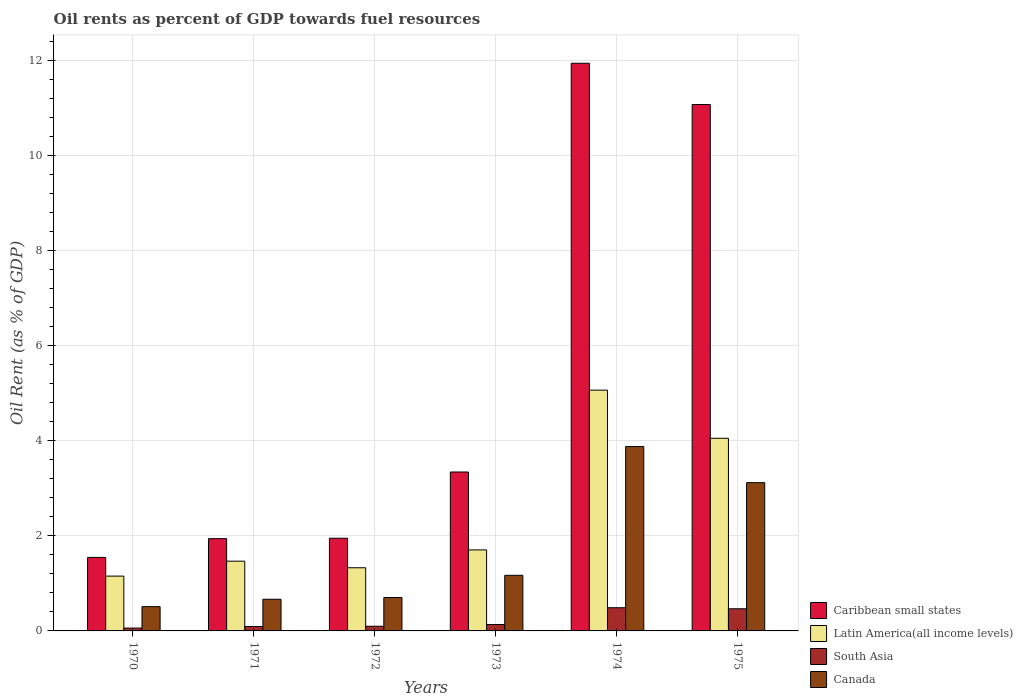How many bars are there on the 1st tick from the left?
Your answer should be compact. 4. How many bars are there on the 6th tick from the right?
Your answer should be compact. 4. What is the label of the 3rd group of bars from the left?
Keep it short and to the point. 1972. In how many cases, is the number of bars for a given year not equal to the number of legend labels?
Keep it short and to the point. 0. What is the oil rent in Canada in 1971?
Offer a terse response. 0.67. Across all years, what is the maximum oil rent in Latin America(all income levels)?
Your answer should be compact. 5.06. Across all years, what is the minimum oil rent in Canada?
Your answer should be compact. 0.51. In which year was the oil rent in Latin America(all income levels) maximum?
Your answer should be compact. 1974. In which year was the oil rent in South Asia minimum?
Provide a short and direct response. 1970. What is the total oil rent in Latin America(all income levels) in the graph?
Your answer should be compact. 14.76. What is the difference between the oil rent in South Asia in 1970 and that in 1971?
Keep it short and to the point. -0.03. What is the difference between the oil rent in Latin America(all income levels) in 1970 and the oil rent in Caribbean small states in 1972?
Offer a very short reply. -0.8. What is the average oil rent in Latin America(all income levels) per year?
Your answer should be very brief. 2.46. In the year 1974, what is the difference between the oil rent in Canada and oil rent in Latin America(all income levels)?
Offer a terse response. -1.19. In how many years, is the oil rent in Canada greater than 4 %?
Provide a short and direct response. 0. What is the ratio of the oil rent in Caribbean small states in 1971 to that in 1975?
Your response must be concise. 0.18. Is the difference between the oil rent in Canada in 1971 and 1973 greater than the difference between the oil rent in Latin America(all income levels) in 1971 and 1973?
Offer a very short reply. No. What is the difference between the highest and the second highest oil rent in Caribbean small states?
Make the answer very short. 0.87. What is the difference between the highest and the lowest oil rent in Caribbean small states?
Keep it short and to the point. 10.39. What does the 3rd bar from the left in 1975 represents?
Offer a terse response. South Asia. What does the 4th bar from the right in 1970 represents?
Your answer should be very brief. Caribbean small states. How many bars are there?
Offer a terse response. 24. Are all the bars in the graph horizontal?
Keep it short and to the point. No. Does the graph contain grids?
Your response must be concise. Yes. How many legend labels are there?
Your answer should be compact. 4. What is the title of the graph?
Ensure brevity in your answer.  Oil rents as percent of GDP towards fuel resources. What is the label or title of the Y-axis?
Your answer should be very brief. Oil Rent (as % of GDP). What is the Oil Rent (as % of GDP) of Caribbean small states in 1970?
Keep it short and to the point. 1.55. What is the Oil Rent (as % of GDP) of Latin America(all income levels) in 1970?
Offer a very short reply. 1.15. What is the Oil Rent (as % of GDP) in South Asia in 1970?
Ensure brevity in your answer.  0.06. What is the Oil Rent (as % of GDP) of Canada in 1970?
Your response must be concise. 0.51. What is the Oil Rent (as % of GDP) of Caribbean small states in 1971?
Keep it short and to the point. 1.94. What is the Oil Rent (as % of GDP) of Latin America(all income levels) in 1971?
Ensure brevity in your answer.  1.47. What is the Oil Rent (as % of GDP) in South Asia in 1971?
Provide a succinct answer. 0.09. What is the Oil Rent (as % of GDP) in Canada in 1971?
Give a very brief answer. 0.67. What is the Oil Rent (as % of GDP) in Caribbean small states in 1972?
Your answer should be very brief. 1.95. What is the Oil Rent (as % of GDP) of Latin America(all income levels) in 1972?
Provide a short and direct response. 1.33. What is the Oil Rent (as % of GDP) in South Asia in 1972?
Provide a short and direct response. 0.1. What is the Oil Rent (as % of GDP) in Canada in 1972?
Your answer should be very brief. 0.7. What is the Oil Rent (as % of GDP) in Caribbean small states in 1973?
Ensure brevity in your answer.  3.34. What is the Oil Rent (as % of GDP) of Latin America(all income levels) in 1973?
Your answer should be very brief. 1.7. What is the Oil Rent (as % of GDP) in South Asia in 1973?
Offer a terse response. 0.14. What is the Oil Rent (as % of GDP) of Canada in 1973?
Make the answer very short. 1.17. What is the Oil Rent (as % of GDP) of Caribbean small states in 1974?
Offer a terse response. 11.94. What is the Oil Rent (as % of GDP) in Latin America(all income levels) in 1974?
Offer a very short reply. 5.06. What is the Oil Rent (as % of GDP) of South Asia in 1974?
Offer a terse response. 0.49. What is the Oil Rent (as % of GDP) of Canada in 1974?
Your answer should be very brief. 3.88. What is the Oil Rent (as % of GDP) of Caribbean small states in 1975?
Your answer should be compact. 11.07. What is the Oil Rent (as % of GDP) in Latin America(all income levels) in 1975?
Provide a succinct answer. 4.05. What is the Oil Rent (as % of GDP) in South Asia in 1975?
Provide a short and direct response. 0.47. What is the Oil Rent (as % of GDP) in Canada in 1975?
Provide a succinct answer. 3.12. Across all years, what is the maximum Oil Rent (as % of GDP) of Caribbean small states?
Make the answer very short. 11.94. Across all years, what is the maximum Oil Rent (as % of GDP) in Latin America(all income levels)?
Your answer should be compact. 5.06. Across all years, what is the maximum Oil Rent (as % of GDP) of South Asia?
Make the answer very short. 0.49. Across all years, what is the maximum Oil Rent (as % of GDP) of Canada?
Ensure brevity in your answer.  3.88. Across all years, what is the minimum Oil Rent (as % of GDP) of Caribbean small states?
Your response must be concise. 1.55. Across all years, what is the minimum Oil Rent (as % of GDP) of Latin America(all income levels)?
Offer a terse response. 1.15. Across all years, what is the minimum Oil Rent (as % of GDP) in South Asia?
Provide a short and direct response. 0.06. Across all years, what is the minimum Oil Rent (as % of GDP) of Canada?
Ensure brevity in your answer.  0.51. What is the total Oil Rent (as % of GDP) of Caribbean small states in the graph?
Your answer should be compact. 31.78. What is the total Oil Rent (as % of GDP) in Latin America(all income levels) in the graph?
Keep it short and to the point. 14.76. What is the total Oil Rent (as % of GDP) in South Asia in the graph?
Your answer should be compact. 1.34. What is the total Oil Rent (as % of GDP) in Canada in the graph?
Provide a short and direct response. 10.04. What is the difference between the Oil Rent (as % of GDP) in Caribbean small states in 1970 and that in 1971?
Provide a succinct answer. -0.39. What is the difference between the Oil Rent (as % of GDP) of Latin America(all income levels) in 1970 and that in 1971?
Offer a very short reply. -0.31. What is the difference between the Oil Rent (as % of GDP) in South Asia in 1970 and that in 1971?
Offer a terse response. -0.03. What is the difference between the Oil Rent (as % of GDP) in Canada in 1970 and that in 1971?
Offer a terse response. -0.16. What is the difference between the Oil Rent (as % of GDP) in Caribbean small states in 1970 and that in 1972?
Ensure brevity in your answer.  -0.4. What is the difference between the Oil Rent (as % of GDP) in Latin America(all income levels) in 1970 and that in 1972?
Make the answer very short. -0.18. What is the difference between the Oil Rent (as % of GDP) of South Asia in 1970 and that in 1972?
Your answer should be very brief. -0.04. What is the difference between the Oil Rent (as % of GDP) of Canada in 1970 and that in 1972?
Offer a terse response. -0.19. What is the difference between the Oil Rent (as % of GDP) in Caribbean small states in 1970 and that in 1973?
Ensure brevity in your answer.  -1.8. What is the difference between the Oil Rent (as % of GDP) in Latin America(all income levels) in 1970 and that in 1973?
Keep it short and to the point. -0.55. What is the difference between the Oil Rent (as % of GDP) in South Asia in 1970 and that in 1973?
Offer a very short reply. -0.08. What is the difference between the Oil Rent (as % of GDP) of Canada in 1970 and that in 1973?
Offer a very short reply. -0.66. What is the difference between the Oil Rent (as % of GDP) of Caribbean small states in 1970 and that in 1974?
Ensure brevity in your answer.  -10.39. What is the difference between the Oil Rent (as % of GDP) in Latin America(all income levels) in 1970 and that in 1974?
Your response must be concise. -3.91. What is the difference between the Oil Rent (as % of GDP) in South Asia in 1970 and that in 1974?
Provide a short and direct response. -0.43. What is the difference between the Oil Rent (as % of GDP) in Canada in 1970 and that in 1974?
Keep it short and to the point. -3.37. What is the difference between the Oil Rent (as % of GDP) in Caribbean small states in 1970 and that in 1975?
Keep it short and to the point. -9.52. What is the difference between the Oil Rent (as % of GDP) in Latin America(all income levels) in 1970 and that in 1975?
Your response must be concise. -2.9. What is the difference between the Oil Rent (as % of GDP) in South Asia in 1970 and that in 1975?
Ensure brevity in your answer.  -0.41. What is the difference between the Oil Rent (as % of GDP) of Canada in 1970 and that in 1975?
Provide a short and direct response. -2.61. What is the difference between the Oil Rent (as % of GDP) in Caribbean small states in 1971 and that in 1972?
Your answer should be very brief. -0.01. What is the difference between the Oil Rent (as % of GDP) of Latin America(all income levels) in 1971 and that in 1972?
Your response must be concise. 0.14. What is the difference between the Oil Rent (as % of GDP) of South Asia in 1971 and that in 1972?
Offer a very short reply. -0.01. What is the difference between the Oil Rent (as % of GDP) of Canada in 1971 and that in 1972?
Give a very brief answer. -0.04. What is the difference between the Oil Rent (as % of GDP) of Caribbean small states in 1971 and that in 1973?
Keep it short and to the point. -1.4. What is the difference between the Oil Rent (as % of GDP) in Latin America(all income levels) in 1971 and that in 1973?
Provide a succinct answer. -0.24. What is the difference between the Oil Rent (as % of GDP) of South Asia in 1971 and that in 1973?
Ensure brevity in your answer.  -0.04. What is the difference between the Oil Rent (as % of GDP) of Canada in 1971 and that in 1973?
Your response must be concise. -0.5. What is the difference between the Oil Rent (as % of GDP) of Caribbean small states in 1971 and that in 1974?
Offer a very short reply. -10. What is the difference between the Oil Rent (as % of GDP) in Latin America(all income levels) in 1971 and that in 1974?
Make the answer very short. -3.6. What is the difference between the Oil Rent (as % of GDP) in South Asia in 1971 and that in 1974?
Give a very brief answer. -0.39. What is the difference between the Oil Rent (as % of GDP) of Canada in 1971 and that in 1974?
Offer a very short reply. -3.21. What is the difference between the Oil Rent (as % of GDP) of Caribbean small states in 1971 and that in 1975?
Keep it short and to the point. -9.13. What is the difference between the Oil Rent (as % of GDP) of Latin America(all income levels) in 1971 and that in 1975?
Provide a short and direct response. -2.58. What is the difference between the Oil Rent (as % of GDP) of South Asia in 1971 and that in 1975?
Your response must be concise. -0.37. What is the difference between the Oil Rent (as % of GDP) of Canada in 1971 and that in 1975?
Your response must be concise. -2.45. What is the difference between the Oil Rent (as % of GDP) in Caribbean small states in 1972 and that in 1973?
Give a very brief answer. -1.39. What is the difference between the Oil Rent (as % of GDP) of Latin America(all income levels) in 1972 and that in 1973?
Offer a terse response. -0.38. What is the difference between the Oil Rent (as % of GDP) in South Asia in 1972 and that in 1973?
Provide a succinct answer. -0.04. What is the difference between the Oil Rent (as % of GDP) in Canada in 1972 and that in 1973?
Your response must be concise. -0.47. What is the difference between the Oil Rent (as % of GDP) in Caribbean small states in 1972 and that in 1974?
Offer a terse response. -9.99. What is the difference between the Oil Rent (as % of GDP) in Latin America(all income levels) in 1972 and that in 1974?
Your answer should be compact. -3.73. What is the difference between the Oil Rent (as % of GDP) of South Asia in 1972 and that in 1974?
Ensure brevity in your answer.  -0.39. What is the difference between the Oil Rent (as % of GDP) of Canada in 1972 and that in 1974?
Your answer should be compact. -3.17. What is the difference between the Oil Rent (as % of GDP) of Caribbean small states in 1972 and that in 1975?
Your response must be concise. -9.12. What is the difference between the Oil Rent (as % of GDP) in Latin America(all income levels) in 1972 and that in 1975?
Offer a terse response. -2.72. What is the difference between the Oil Rent (as % of GDP) in South Asia in 1972 and that in 1975?
Ensure brevity in your answer.  -0.37. What is the difference between the Oil Rent (as % of GDP) of Canada in 1972 and that in 1975?
Your response must be concise. -2.42. What is the difference between the Oil Rent (as % of GDP) of Caribbean small states in 1973 and that in 1974?
Ensure brevity in your answer.  -8.59. What is the difference between the Oil Rent (as % of GDP) in Latin America(all income levels) in 1973 and that in 1974?
Your answer should be very brief. -3.36. What is the difference between the Oil Rent (as % of GDP) of South Asia in 1973 and that in 1974?
Provide a short and direct response. -0.35. What is the difference between the Oil Rent (as % of GDP) in Canada in 1973 and that in 1974?
Offer a very short reply. -2.71. What is the difference between the Oil Rent (as % of GDP) of Caribbean small states in 1973 and that in 1975?
Give a very brief answer. -7.73. What is the difference between the Oil Rent (as % of GDP) in Latin America(all income levels) in 1973 and that in 1975?
Ensure brevity in your answer.  -2.35. What is the difference between the Oil Rent (as % of GDP) of South Asia in 1973 and that in 1975?
Offer a very short reply. -0.33. What is the difference between the Oil Rent (as % of GDP) in Canada in 1973 and that in 1975?
Your answer should be compact. -1.95. What is the difference between the Oil Rent (as % of GDP) of Caribbean small states in 1974 and that in 1975?
Keep it short and to the point. 0.87. What is the difference between the Oil Rent (as % of GDP) in Latin America(all income levels) in 1974 and that in 1975?
Make the answer very short. 1.01. What is the difference between the Oil Rent (as % of GDP) in South Asia in 1974 and that in 1975?
Make the answer very short. 0.02. What is the difference between the Oil Rent (as % of GDP) of Canada in 1974 and that in 1975?
Keep it short and to the point. 0.76. What is the difference between the Oil Rent (as % of GDP) of Caribbean small states in 1970 and the Oil Rent (as % of GDP) of Latin America(all income levels) in 1971?
Provide a succinct answer. 0.08. What is the difference between the Oil Rent (as % of GDP) in Caribbean small states in 1970 and the Oil Rent (as % of GDP) in South Asia in 1971?
Provide a succinct answer. 1.45. What is the difference between the Oil Rent (as % of GDP) of Caribbean small states in 1970 and the Oil Rent (as % of GDP) of Canada in 1971?
Offer a terse response. 0.88. What is the difference between the Oil Rent (as % of GDP) in Latin America(all income levels) in 1970 and the Oil Rent (as % of GDP) in South Asia in 1971?
Your answer should be compact. 1.06. What is the difference between the Oil Rent (as % of GDP) of Latin America(all income levels) in 1970 and the Oil Rent (as % of GDP) of Canada in 1971?
Offer a very short reply. 0.49. What is the difference between the Oil Rent (as % of GDP) in South Asia in 1970 and the Oil Rent (as % of GDP) in Canada in 1971?
Keep it short and to the point. -0.61. What is the difference between the Oil Rent (as % of GDP) of Caribbean small states in 1970 and the Oil Rent (as % of GDP) of Latin America(all income levels) in 1972?
Your response must be concise. 0.22. What is the difference between the Oil Rent (as % of GDP) in Caribbean small states in 1970 and the Oil Rent (as % of GDP) in South Asia in 1972?
Offer a terse response. 1.45. What is the difference between the Oil Rent (as % of GDP) of Caribbean small states in 1970 and the Oil Rent (as % of GDP) of Canada in 1972?
Your answer should be very brief. 0.84. What is the difference between the Oil Rent (as % of GDP) of Latin America(all income levels) in 1970 and the Oil Rent (as % of GDP) of South Asia in 1972?
Give a very brief answer. 1.05. What is the difference between the Oil Rent (as % of GDP) in Latin America(all income levels) in 1970 and the Oil Rent (as % of GDP) in Canada in 1972?
Offer a very short reply. 0.45. What is the difference between the Oil Rent (as % of GDP) of South Asia in 1970 and the Oil Rent (as % of GDP) of Canada in 1972?
Provide a succinct answer. -0.64. What is the difference between the Oil Rent (as % of GDP) of Caribbean small states in 1970 and the Oil Rent (as % of GDP) of Latin America(all income levels) in 1973?
Ensure brevity in your answer.  -0.16. What is the difference between the Oil Rent (as % of GDP) in Caribbean small states in 1970 and the Oil Rent (as % of GDP) in South Asia in 1973?
Give a very brief answer. 1.41. What is the difference between the Oil Rent (as % of GDP) of Caribbean small states in 1970 and the Oil Rent (as % of GDP) of Canada in 1973?
Ensure brevity in your answer.  0.38. What is the difference between the Oil Rent (as % of GDP) in Latin America(all income levels) in 1970 and the Oil Rent (as % of GDP) in South Asia in 1973?
Offer a very short reply. 1.02. What is the difference between the Oil Rent (as % of GDP) in Latin America(all income levels) in 1970 and the Oil Rent (as % of GDP) in Canada in 1973?
Provide a short and direct response. -0.02. What is the difference between the Oil Rent (as % of GDP) of South Asia in 1970 and the Oil Rent (as % of GDP) of Canada in 1973?
Keep it short and to the point. -1.11. What is the difference between the Oil Rent (as % of GDP) in Caribbean small states in 1970 and the Oil Rent (as % of GDP) in Latin America(all income levels) in 1974?
Offer a terse response. -3.52. What is the difference between the Oil Rent (as % of GDP) in Caribbean small states in 1970 and the Oil Rent (as % of GDP) in South Asia in 1974?
Your response must be concise. 1.06. What is the difference between the Oil Rent (as % of GDP) in Caribbean small states in 1970 and the Oil Rent (as % of GDP) in Canada in 1974?
Provide a succinct answer. -2.33. What is the difference between the Oil Rent (as % of GDP) in Latin America(all income levels) in 1970 and the Oil Rent (as % of GDP) in South Asia in 1974?
Your response must be concise. 0.66. What is the difference between the Oil Rent (as % of GDP) in Latin America(all income levels) in 1970 and the Oil Rent (as % of GDP) in Canada in 1974?
Ensure brevity in your answer.  -2.72. What is the difference between the Oil Rent (as % of GDP) in South Asia in 1970 and the Oil Rent (as % of GDP) in Canada in 1974?
Offer a very short reply. -3.82. What is the difference between the Oil Rent (as % of GDP) in Caribbean small states in 1970 and the Oil Rent (as % of GDP) in Latin America(all income levels) in 1975?
Ensure brevity in your answer.  -2.5. What is the difference between the Oil Rent (as % of GDP) of Caribbean small states in 1970 and the Oil Rent (as % of GDP) of South Asia in 1975?
Provide a succinct answer. 1.08. What is the difference between the Oil Rent (as % of GDP) of Caribbean small states in 1970 and the Oil Rent (as % of GDP) of Canada in 1975?
Offer a very short reply. -1.57. What is the difference between the Oil Rent (as % of GDP) of Latin America(all income levels) in 1970 and the Oil Rent (as % of GDP) of South Asia in 1975?
Offer a terse response. 0.69. What is the difference between the Oil Rent (as % of GDP) in Latin America(all income levels) in 1970 and the Oil Rent (as % of GDP) in Canada in 1975?
Your answer should be very brief. -1.96. What is the difference between the Oil Rent (as % of GDP) in South Asia in 1970 and the Oil Rent (as % of GDP) in Canada in 1975?
Provide a short and direct response. -3.06. What is the difference between the Oil Rent (as % of GDP) of Caribbean small states in 1971 and the Oil Rent (as % of GDP) of Latin America(all income levels) in 1972?
Provide a short and direct response. 0.61. What is the difference between the Oil Rent (as % of GDP) in Caribbean small states in 1971 and the Oil Rent (as % of GDP) in South Asia in 1972?
Give a very brief answer. 1.84. What is the difference between the Oil Rent (as % of GDP) of Caribbean small states in 1971 and the Oil Rent (as % of GDP) of Canada in 1972?
Your answer should be very brief. 1.24. What is the difference between the Oil Rent (as % of GDP) of Latin America(all income levels) in 1971 and the Oil Rent (as % of GDP) of South Asia in 1972?
Provide a succinct answer. 1.37. What is the difference between the Oil Rent (as % of GDP) of Latin America(all income levels) in 1971 and the Oil Rent (as % of GDP) of Canada in 1972?
Your answer should be compact. 0.76. What is the difference between the Oil Rent (as % of GDP) in South Asia in 1971 and the Oil Rent (as % of GDP) in Canada in 1972?
Provide a succinct answer. -0.61. What is the difference between the Oil Rent (as % of GDP) in Caribbean small states in 1971 and the Oil Rent (as % of GDP) in Latin America(all income levels) in 1973?
Ensure brevity in your answer.  0.24. What is the difference between the Oil Rent (as % of GDP) in Caribbean small states in 1971 and the Oil Rent (as % of GDP) in South Asia in 1973?
Keep it short and to the point. 1.81. What is the difference between the Oil Rent (as % of GDP) of Caribbean small states in 1971 and the Oil Rent (as % of GDP) of Canada in 1973?
Keep it short and to the point. 0.77. What is the difference between the Oil Rent (as % of GDP) in Latin America(all income levels) in 1971 and the Oil Rent (as % of GDP) in South Asia in 1973?
Make the answer very short. 1.33. What is the difference between the Oil Rent (as % of GDP) in Latin America(all income levels) in 1971 and the Oil Rent (as % of GDP) in Canada in 1973?
Provide a short and direct response. 0.3. What is the difference between the Oil Rent (as % of GDP) in South Asia in 1971 and the Oil Rent (as % of GDP) in Canada in 1973?
Give a very brief answer. -1.08. What is the difference between the Oil Rent (as % of GDP) of Caribbean small states in 1971 and the Oil Rent (as % of GDP) of Latin America(all income levels) in 1974?
Provide a short and direct response. -3.12. What is the difference between the Oil Rent (as % of GDP) in Caribbean small states in 1971 and the Oil Rent (as % of GDP) in South Asia in 1974?
Offer a very short reply. 1.45. What is the difference between the Oil Rent (as % of GDP) of Caribbean small states in 1971 and the Oil Rent (as % of GDP) of Canada in 1974?
Offer a terse response. -1.94. What is the difference between the Oil Rent (as % of GDP) of Latin America(all income levels) in 1971 and the Oil Rent (as % of GDP) of South Asia in 1974?
Make the answer very short. 0.98. What is the difference between the Oil Rent (as % of GDP) of Latin America(all income levels) in 1971 and the Oil Rent (as % of GDP) of Canada in 1974?
Offer a very short reply. -2.41. What is the difference between the Oil Rent (as % of GDP) of South Asia in 1971 and the Oil Rent (as % of GDP) of Canada in 1974?
Provide a succinct answer. -3.78. What is the difference between the Oil Rent (as % of GDP) of Caribbean small states in 1971 and the Oil Rent (as % of GDP) of Latin America(all income levels) in 1975?
Provide a succinct answer. -2.11. What is the difference between the Oil Rent (as % of GDP) of Caribbean small states in 1971 and the Oil Rent (as % of GDP) of South Asia in 1975?
Your answer should be compact. 1.47. What is the difference between the Oil Rent (as % of GDP) in Caribbean small states in 1971 and the Oil Rent (as % of GDP) in Canada in 1975?
Offer a terse response. -1.18. What is the difference between the Oil Rent (as % of GDP) of Latin America(all income levels) in 1971 and the Oil Rent (as % of GDP) of Canada in 1975?
Keep it short and to the point. -1.65. What is the difference between the Oil Rent (as % of GDP) in South Asia in 1971 and the Oil Rent (as % of GDP) in Canada in 1975?
Your answer should be very brief. -3.02. What is the difference between the Oil Rent (as % of GDP) in Caribbean small states in 1972 and the Oil Rent (as % of GDP) in Latin America(all income levels) in 1973?
Your answer should be very brief. 0.25. What is the difference between the Oil Rent (as % of GDP) of Caribbean small states in 1972 and the Oil Rent (as % of GDP) of South Asia in 1973?
Ensure brevity in your answer.  1.81. What is the difference between the Oil Rent (as % of GDP) of Caribbean small states in 1972 and the Oil Rent (as % of GDP) of Canada in 1973?
Ensure brevity in your answer.  0.78. What is the difference between the Oil Rent (as % of GDP) in Latin America(all income levels) in 1972 and the Oil Rent (as % of GDP) in South Asia in 1973?
Your answer should be very brief. 1.19. What is the difference between the Oil Rent (as % of GDP) of Latin America(all income levels) in 1972 and the Oil Rent (as % of GDP) of Canada in 1973?
Provide a short and direct response. 0.16. What is the difference between the Oil Rent (as % of GDP) in South Asia in 1972 and the Oil Rent (as % of GDP) in Canada in 1973?
Offer a terse response. -1.07. What is the difference between the Oil Rent (as % of GDP) of Caribbean small states in 1972 and the Oil Rent (as % of GDP) of Latin America(all income levels) in 1974?
Keep it short and to the point. -3.11. What is the difference between the Oil Rent (as % of GDP) of Caribbean small states in 1972 and the Oil Rent (as % of GDP) of South Asia in 1974?
Your answer should be compact. 1.46. What is the difference between the Oil Rent (as % of GDP) of Caribbean small states in 1972 and the Oil Rent (as % of GDP) of Canada in 1974?
Your answer should be compact. -1.93. What is the difference between the Oil Rent (as % of GDP) in Latin America(all income levels) in 1972 and the Oil Rent (as % of GDP) in South Asia in 1974?
Keep it short and to the point. 0.84. What is the difference between the Oil Rent (as % of GDP) in Latin America(all income levels) in 1972 and the Oil Rent (as % of GDP) in Canada in 1974?
Give a very brief answer. -2.55. What is the difference between the Oil Rent (as % of GDP) in South Asia in 1972 and the Oil Rent (as % of GDP) in Canada in 1974?
Offer a very short reply. -3.78. What is the difference between the Oil Rent (as % of GDP) in Caribbean small states in 1972 and the Oil Rent (as % of GDP) in Latin America(all income levels) in 1975?
Offer a very short reply. -2.1. What is the difference between the Oil Rent (as % of GDP) in Caribbean small states in 1972 and the Oil Rent (as % of GDP) in South Asia in 1975?
Give a very brief answer. 1.48. What is the difference between the Oil Rent (as % of GDP) in Caribbean small states in 1972 and the Oil Rent (as % of GDP) in Canada in 1975?
Keep it short and to the point. -1.17. What is the difference between the Oil Rent (as % of GDP) of Latin America(all income levels) in 1972 and the Oil Rent (as % of GDP) of South Asia in 1975?
Offer a very short reply. 0.86. What is the difference between the Oil Rent (as % of GDP) in Latin America(all income levels) in 1972 and the Oil Rent (as % of GDP) in Canada in 1975?
Your answer should be very brief. -1.79. What is the difference between the Oil Rent (as % of GDP) in South Asia in 1972 and the Oil Rent (as % of GDP) in Canada in 1975?
Provide a succinct answer. -3.02. What is the difference between the Oil Rent (as % of GDP) of Caribbean small states in 1973 and the Oil Rent (as % of GDP) of Latin America(all income levels) in 1974?
Make the answer very short. -1.72. What is the difference between the Oil Rent (as % of GDP) of Caribbean small states in 1973 and the Oil Rent (as % of GDP) of South Asia in 1974?
Provide a succinct answer. 2.85. What is the difference between the Oil Rent (as % of GDP) in Caribbean small states in 1973 and the Oil Rent (as % of GDP) in Canada in 1974?
Your response must be concise. -0.53. What is the difference between the Oil Rent (as % of GDP) of Latin America(all income levels) in 1973 and the Oil Rent (as % of GDP) of South Asia in 1974?
Offer a terse response. 1.22. What is the difference between the Oil Rent (as % of GDP) in Latin America(all income levels) in 1973 and the Oil Rent (as % of GDP) in Canada in 1974?
Provide a short and direct response. -2.17. What is the difference between the Oil Rent (as % of GDP) of South Asia in 1973 and the Oil Rent (as % of GDP) of Canada in 1974?
Make the answer very short. -3.74. What is the difference between the Oil Rent (as % of GDP) of Caribbean small states in 1973 and the Oil Rent (as % of GDP) of Latin America(all income levels) in 1975?
Give a very brief answer. -0.71. What is the difference between the Oil Rent (as % of GDP) of Caribbean small states in 1973 and the Oil Rent (as % of GDP) of South Asia in 1975?
Offer a very short reply. 2.88. What is the difference between the Oil Rent (as % of GDP) in Caribbean small states in 1973 and the Oil Rent (as % of GDP) in Canada in 1975?
Provide a succinct answer. 0.22. What is the difference between the Oil Rent (as % of GDP) of Latin America(all income levels) in 1973 and the Oil Rent (as % of GDP) of South Asia in 1975?
Offer a very short reply. 1.24. What is the difference between the Oil Rent (as % of GDP) in Latin America(all income levels) in 1973 and the Oil Rent (as % of GDP) in Canada in 1975?
Make the answer very short. -1.41. What is the difference between the Oil Rent (as % of GDP) of South Asia in 1973 and the Oil Rent (as % of GDP) of Canada in 1975?
Provide a succinct answer. -2.98. What is the difference between the Oil Rent (as % of GDP) in Caribbean small states in 1974 and the Oil Rent (as % of GDP) in Latin America(all income levels) in 1975?
Provide a short and direct response. 7.89. What is the difference between the Oil Rent (as % of GDP) in Caribbean small states in 1974 and the Oil Rent (as % of GDP) in South Asia in 1975?
Offer a terse response. 11.47. What is the difference between the Oil Rent (as % of GDP) in Caribbean small states in 1974 and the Oil Rent (as % of GDP) in Canada in 1975?
Provide a short and direct response. 8.82. What is the difference between the Oil Rent (as % of GDP) in Latin America(all income levels) in 1974 and the Oil Rent (as % of GDP) in South Asia in 1975?
Your answer should be very brief. 4.6. What is the difference between the Oil Rent (as % of GDP) of Latin America(all income levels) in 1974 and the Oil Rent (as % of GDP) of Canada in 1975?
Your answer should be very brief. 1.95. What is the difference between the Oil Rent (as % of GDP) in South Asia in 1974 and the Oil Rent (as % of GDP) in Canada in 1975?
Ensure brevity in your answer.  -2.63. What is the average Oil Rent (as % of GDP) of Caribbean small states per year?
Offer a very short reply. 5.3. What is the average Oil Rent (as % of GDP) of Latin America(all income levels) per year?
Keep it short and to the point. 2.46. What is the average Oil Rent (as % of GDP) of South Asia per year?
Your answer should be very brief. 0.22. What is the average Oil Rent (as % of GDP) in Canada per year?
Offer a very short reply. 1.67. In the year 1970, what is the difference between the Oil Rent (as % of GDP) of Caribbean small states and Oil Rent (as % of GDP) of Latin America(all income levels)?
Offer a very short reply. 0.39. In the year 1970, what is the difference between the Oil Rent (as % of GDP) of Caribbean small states and Oil Rent (as % of GDP) of South Asia?
Your response must be concise. 1.49. In the year 1970, what is the difference between the Oil Rent (as % of GDP) of Caribbean small states and Oil Rent (as % of GDP) of Canada?
Give a very brief answer. 1.04. In the year 1970, what is the difference between the Oil Rent (as % of GDP) in Latin America(all income levels) and Oil Rent (as % of GDP) in South Asia?
Your answer should be compact. 1.09. In the year 1970, what is the difference between the Oil Rent (as % of GDP) of Latin America(all income levels) and Oil Rent (as % of GDP) of Canada?
Offer a terse response. 0.64. In the year 1970, what is the difference between the Oil Rent (as % of GDP) in South Asia and Oil Rent (as % of GDP) in Canada?
Your answer should be compact. -0.45. In the year 1971, what is the difference between the Oil Rent (as % of GDP) in Caribbean small states and Oil Rent (as % of GDP) in Latin America(all income levels)?
Make the answer very short. 0.47. In the year 1971, what is the difference between the Oil Rent (as % of GDP) in Caribbean small states and Oil Rent (as % of GDP) in South Asia?
Offer a terse response. 1.85. In the year 1971, what is the difference between the Oil Rent (as % of GDP) in Caribbean small states and Oil Rent (as % of GDP) in Canada?
Your answer should be compact. 1.27. In the year 1971, what is the difference between the Oil Rent (as % of GDP) in Latin America(all income levels) and Oil Rent (as % of GDP) in South Asia?
Offer a terse response. 1.37. In the year 1971, what is the difference between the Oil Rent (as % of GDP) in Latin America(all income levels) and Oil Rent (as % of GDP) in Canada?
Make the answer very short. 0.8. In the year 1971, what is the difference between the Oil Rent (as % of GDP) in South Asia and Oil Rent (as % of GDP) in Canada?
Keep it short and to the point. -0.57. In the year 1972, what is the difference between the Oil Rent (as % of GDP) in Caribbean small states and Oil Rent (as % of GDP) in Latin America(all income levels)?
Keep it short and to the point. 0.62. In the year 1972, what is the difference between the Oil Rent (as % of GDP) of Caribbean small states and Oil Rent (as % of GDP) of South Asia?
Keep it short and to the point. 1.85. In the year 1972, what is the difference between the Oil Rent (as % of GDP) of Caribbean small states and Oil Rent (as % of GDP) of Canada?
Keep it short and to the point. 1.25. In the year 1972, what is the difference between the Oil Rent (as % of GDP) of Latin America(all income levels) and Oil Rent (as % of GDP) of South Asia?
Make the answer very short. 1.23. In the year 1972, what is the difference between the Oil Rent (as % of GDP) of Latin America(all income levels) and Oil Rent (as % of GDP) of Canada?
Give a very brief answer. 0.63. In the year 1972, what is the difference between the Oil Rent (as % of GDP) of South Asia and Oil Rent (as % of GDP) of Canada?
Keep it short and to the point. -0.6. In the year 1973, what is the difference between the Oil Rent (as % of GDP) in Caribbean small states and Oil Rent (as % of GDP) in Latin America(all income levels)?
Your answer should be very brief. 1.64. In the year 1973, what is the difference between the Oil Rent (as % of GDP) of Caribbean small states and Oil Rent (as % of GDP) of South Asia?
Make the answer very short. 3.21. In the year 1973, what is the difference between the Oil Rent (as % of GDP) in Caribbean small states and Oil Rent (as % of GDP) in Canada?
Your answer should be very brief. 2.17. In the year 1973, what is the difference between the Oil Rent (as % of GDP) in Latin America(all income levels) and Oil Rent (as % of GDP) in South Asia?
Your response must be concise. 1.57. In the year 1973, what is the difference between the Oil Rent (as % of GDP) in Latin America(all income levels) and Oil Rent (as % of GDP) in Canada?
Make the answer very short. 0.53. In the year 1973, what is the difference between the Oil Rent (as % of GDP) of South Asia and Oil Rent (as % of GDP) of Canada?
Provide a short and direct response. -1.03. In the year 1974, what is the difference between the Oil Rent (as % of GDP) in Caribbean small states and Oil Rent (as % of GDP) in Latin America(all income levels)?
Keep it short and to the point. 6.87. In the year 1974, what is the difference between the Oil Rent (as % of GDP) in Caribbean small states and Oil Rent (as % of GDP) in South Asia?
Give a very brief answer. 11.45. In the year 1974, what is the difference between the Oil Rent (as % of GDP) of Caribbean small states and Oil Rent (as % of GDP) of Canada?
Provide a succinct answer. 8.06. In the year 1974, what is the difference between the Oil Rent (as % of GDP) of Latin America(all income levels) and Oil Rent (as % of GDP) of South Asia?
Your answer should be compact. 4.57. In the year 1974, what is the difference between the Oil Rent (as % of GDP) of Latin America(all income levels) and Oil Rent (as % of GDP) of Canada?
Offer a very short reply. 1.19. In the year 1974, what is the difference between the Oil Rent (as % of GDP) in South Asia and Oil Rent (as % of GDP) in Canada?
Your answer should be compact. -3.39. In the year 1975, what is the difference between the Oil Rent (as % of GDP) in Caribbean small states and Oil Rent (as % of GDP) in Latin America(all income levels)?
Your response must be concise. 7.02. In the year 1975, what is the difference between the Oil Rent (as % of GDP) of Caribbean small states and Oil Rent (as % of GDP) of South Asia?
Keep it short and to the point. 10.6. In the year 1975, what is the difference between the Oil Rent (as % of GDP) in Caribbean small states and Oil Rent (as % of GDP) in Canada?
Your answer should be compact. 7.95. In the year 1975, what is the difference between the Oil Rent (as % of GDP) of Latin America(all income levels) and Oil Rent (as % of GDP) of South Asia?
Provide a short and direct response. 3.58. In the year 1975, what is the difference between the Oil Rent (as % of GDP) in Latin America(all income levels) and Oil Rent (as % of GDP) in Canada?
Your answer should be very brief. 0.93. In the year 1975, what is the difference between the Oil Rent (as % of GDP) in South Asia and Oil Rent (as % of GDP) in Canada?
Ensure brevity in your answer.  -2.65. What is the ratio of the Oil Rent (as % of GDP) of Caribbean small states in 1970 to that in 1971?
Your response must be concise. 0.8. What is the ratio of the Oil Rent (as % of GDP) of Latin America(all income levels) in 1970 to that in 1971?
Provide a succinct answer. 0.79. What is the ratio of the Oil Rent (as % of GDP) of South Asia in 1970 to that in 1971?
Ensure brevity in your answer.  0.64. What is the ratio of the Oil Rent (as % of GDP) of Canada in 1970 to that in 1971?
Provide a succinct answer. 0.77. What is the ratio of the Oil Rent (as % of GDP) of Caribbean small states in 1970 to that in 1972?
Keep it short and to the point. 0.79. What is the ratio of the Oil Rent (as % of GDP) in Latin America(all income levels) in 1970 to that in 1972?
Offer a very short reply. 0.87. What is the ratio of the Oil Rent (as % of GDP) of South Asia in 1970 to that in 1972?
Offer a terse response. 0.61. What is the ratio of the Oil Rent (as % of GDP) in Canada in 1970 to that in 1972?
Your answer should be very brief. 0.73. What is the ratio of the Oil Rent (as % of GDP) in Caribbean small states in 1970 to that in 1973?
Your response must be concise. 0.46. What is the ratio of the Oil Rent (as % of GDP) of Latin America(all income levels) in 1970 to that in 1973?
Your answer should be very brief. 0.68. What is the ratio of the Oil Rent (as % of GDP) of South Asia in 1970 to that in 1973?
Your response must be concise. 0.44. What is the ratio of the Oil Rent (as % of GDP) of Canada in 1970 to that in 1973?
Your response must be concise. 0.44. What is the ratio of the Oil Rent (as % of GDP) in Caribbean small states in 1970 to that in 1974?
Give a very brief answer. 0.13. What is the ratio of the Oil Rent (as % of GDP) in Latin America(all income levels) in 1970 to that in 1974?
Your response must be concise. 0.23. What is the ratio of the Oil Rent (as % of GDP) in South Asia in 1970 to that in 1974?
Provide a short and direct response. 0.12. What is the ratio of the Oil Rent (as % of GDP) in Canada in 1970 to that in 1974?
Make the answer very short. 0.13. What is the ratio of the Oil Rent (as % of GDP) in Caribbean small states in 1970 to that in 1975?
Ensure brevity in your answer.  0.14. What is the ratio of the Oil Rent (as % of GDP) in Latin America(all income levels) in 1970 to that in 1975?
Offer a terse response. 0.28. What is the ratio of the Oil Rent (as % of GDP) in South Asia in 1970 to that in 1975?
Give a very brief answer. 0.13. What is the ratio of the Oil Rent (as % of GDP) of Canada in 1970 to that in 1975?
Provide a succinct answer. 0.16. What is the ratio of the Oil Rent (as % of GDP) in Caribbean small states in 1971 to that in 1972?
Provide a short and direct response. 1. What is the ratio of the Oil Rent (as % of GDP) in Latin America(all income levels) in 1971 to that in 1972?
Ensure brevity in your answer.  1.1. What is the ratio of the Oil Rent (as % of GDP) of South Asia in 1971 to that in 1972?
Your answer should be compact. 0.95. What is the ratio of the Oil Rent (as % of GDP) in Canada in 1971 to that in 1972?
Keep it short and to the point. 0.95. What is the ratio of the Oil Rent (as % of GDP) of Caribbean small states in 1971 to that in 1973?
Offer a terse response. 0.58. What is the ratio of the Oil Rent (as % of GDP) of Latin America(all income levels) in 1971 to that in 1973?
Your answer should be very brief. 0.86. What is the ratio of the Oil Rent (as % of GDP) of South Asia in 1971 to that in 1973?
Keep it short and to the point. 0.69. What is the ratio of the Oil Rent (as % of GDP) in Canada in 1971 to that in 1973?
Make the answer very short. 0.57. What is the ratio of the Oil Rent (as % of GDP) of Caribbean small states in 1971 to that in 1974?
Ensure brevity in your answer.  0.16. What is the ratio of the Oil Rent (as % of GDP) in Latin America(all income levels) in 1971 to that in 1974?
Offer a very short reply. 0.29. What is the ratio of the Oil Rent (as % of GDP) in South Asia in 1971 to that in 1974?
Ensure brevity in your answer.  0.19. What is the ratio of the Oil Rent (as % of GDP) of Canada in 1971 to that in 1974?
Your response must be concise. 0.17. What is the ratio of the Oil Rent (as % of GDP) of Caribbean small states in 1971 to that in 1975?
Make the answer very short. 0.18. What is the ratio of the Oil Rent (as % of GDP) of Latin America(all income levels) in 1971 to that in 1975?
Your answer should be very brief. 0.36. What is the ratio of the Oil Rent (as % of GDP) in South Asia in 1971 to that in 1975?
Your response must be concise. 0.2. What is the ratio of the Oil Rent (as % of GDP) of Canada in 1971 to that in 1975?
Provide a succinct answer. 0.21. What is the ratio of the Oil Rent (as % of GDP) in Caribbean small states in 1972 to that in 1973?
Make the answer very short. 0.58. What is the ratio of the Oil Rent (as % of GDP) in Latin America(all income levels) in 1972 to that in 1973?
Your answer should be very brief. 0.78. What is the ratio of the Oil Rent (as % of GDP) in South Asia in 1972 to that in 1973?
Give a very brief answer. 0.73. What is the ratio of the Oil Rent (as % of GDP) of Canada in 1972 to that in 1973?
Keep it short and to the point. 0.6. What is the ratio of the Oil Rent (as % of GDP) of Caribbean small states in 1972 to that in 1974?
Offer a very short reply. 0.16. What is the ratio of the Oil Rent (as % of GDP) of Latin America(all income levels) in 1972 to that in 1974?
Provide a short and direct response. 0.26. What is the ratio of the Oil Rent (as % of GDP) of South Asia in 1972 to that in 1974?
Your answer should be very brief. 0.2. What is the ratio of the Oil Rent (as % of GDP) in Canada in 1972 to that in 1974?
Your answer should be very brief. 0.18. What is the ratio of the Oil Rent (as % of GDP) of Caribbean small states in 1972 to that in 1975?
Provide a short and direct response. 0.18. What is the ratio of the Oil Rent (as % of GDP) in Latin America(all income levels) in 1972 to that in 1975?
Make the answer very short. 0.33. What is the ratio of the Oil Rent (as % of GDP) of South Asia in 1972 to that in 1975?
Provide a succinct answer. 0.21. What is the ratio of the Oil Rent (as % of GDP) of Canada in 1972 to that in 1975?
Give a very brief answer. 0.23. What is the ratio of the Oil Rent (as % of GDP) in Caribbean small states in 1973 to that in 1974?
Provide a short and direct response. 0.28. What is the ratio of the Oil Rent (as % of GDP) of Latin America(all income levels) in 1973 to that in 1974?
Provide a succinct answer. 0.34. What is the ratio of the Oil Rent (as % of GDP) of South Asia in 1973 to that in 1974?
Make the answer very short. 0.28. What is the ratio of the Oil Rent (as % of GDP) in Canada in 1973 to that in 1974?
Your response must be concise. 0.3. What is the ratio of the Oil Rent (as % of GDP) of Caribbean small states in 1973 to that in 1975?
Ensure brevity in your answer.  0.3. What is the ratio of the Oil Rent (as % of GDP) of Latin America(all income levels) in 1973 to that in 1975?
Provide a succinct answer. 0.42. What is the ratio of the Oil Rent (as % of GDP) of South Asia in 1973 to that in 1975?
Offer a very short reply. 0.29. What is the ratio of the Oil Rent (as % of GDP) in Canada in 1973 to that in 1975?
Your response must be concise. 0.38. What is the ratio of the Oil Rent (as % of GDP) in Caribbean small states in 1974 to that in 1975?
Provide a short and direct response. 1.08. What is the ratio of the Oil Rent (as % of GDP) in Latin America(all income levels) in 1974 to that in 1975?
Provide a short and direct response. 1.25. What is the ratio of the Oil Rent (as % of GDP) of South Asia in 1974 to that in 1975?
Provide a succinct answer. 1.05. What is the ratio of the Oil Rent (as % of GDP) in Canada in 1974 to that in 1975?
Offer a terse response. 1.24. What is the difference between the highest and the second highest Oil Rent (as % of GDP) of Caribbean small states?
Your response must be concise. 0.87. What is the difference between the highest and the second highest Oil Rent (as % of GDP) of Latin America(all income levels)?
Ensure brevity in your answer.  1.01. What is the difference between the highest and the second highest Oil Rent (as % of GDP) in South Asia?
Your answer should be compact. 0.02. What is the difference between the highest and the second highest Oil Rent (as % of GDP) in Canada?
Ensure brevity in your answer.  0.76. What is the difference between the highest and the lowest Oil Rent (as % of GDP) in Caribbean small states?
Offer a terse response. 10.39. What is the difference between the highest and the lowest Oil Rent (as % of GDP) of Latin America(all income levels)?
Provide a succinct answer. 3.91. What is the difference between the highest and the lowest Oil Rent (as % of GDP) in South Asia?
Your response must be concise. 0.43. What is the difference between the highest and the lowest Oil Rent (as % of GDP) of Canada?
Your answer should be very brief. 3.37. 